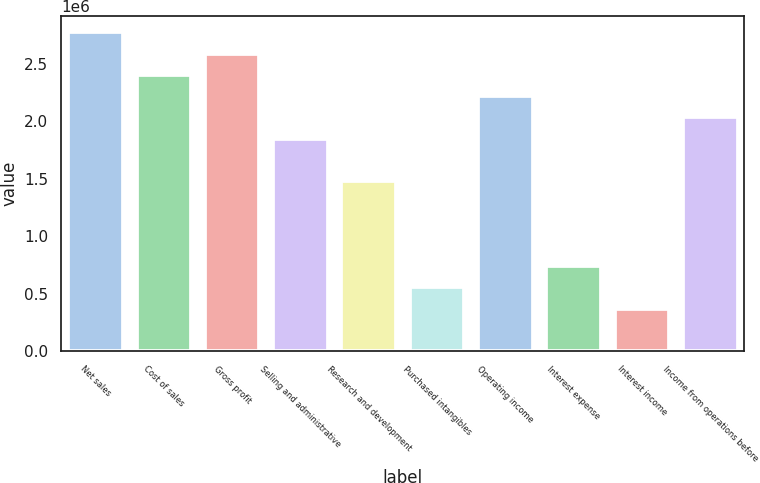Convert chart. <chart><loc_0><loc_0><loc_500><loc_500><bar_chart><fcel>Net sales<fcel>Cost of sales<fcel>Gross profit<fcel>Selling and administrative<fcel>Research and development<fcel>Purchased intangibles<fcel>Operating income<fcel>Interest expense<fcel>Interest income<fcel>Income from operations before<nl><fcel>2.77677e+06<fcel>2.40654e+06<fcel>2.59166e+06<fcel>1.85118e+06<fcel>1.48095e+06<fcel>555358<fcel>2.22142e+06<fcel>740476<fcel>370241<fcel>2.0363e+06<nl></chart> 